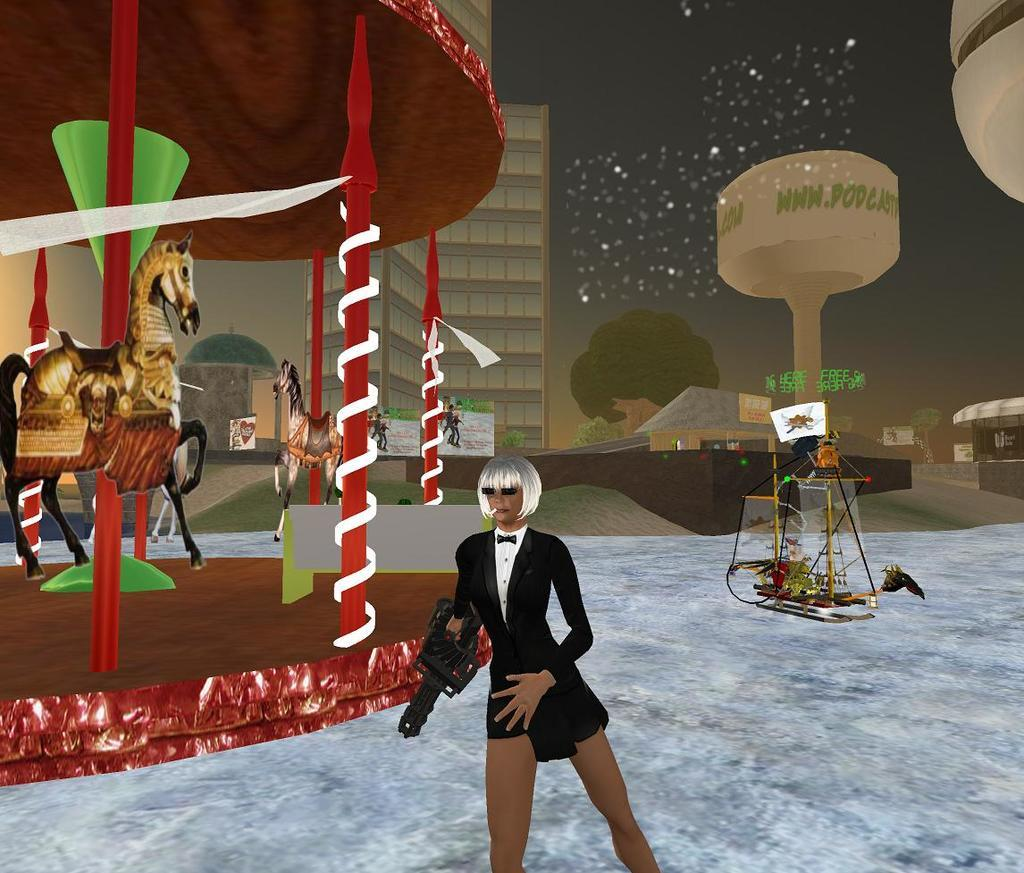What type of image is being described? The image is animated. Who is the main subject in the image? There is a lady in the center of the image. What is the lady wearing? The lady is wearing a black color suit. What can be seen in the background of the image? There is a building and a water tank in the background of the image. What type of church can be seen in the background of the image? There is no church present in the background of the image; it features a building and a water tank. How many crackers are visible on the lady's suit in the image? There are no crackers present on the lady's suit in the image. 